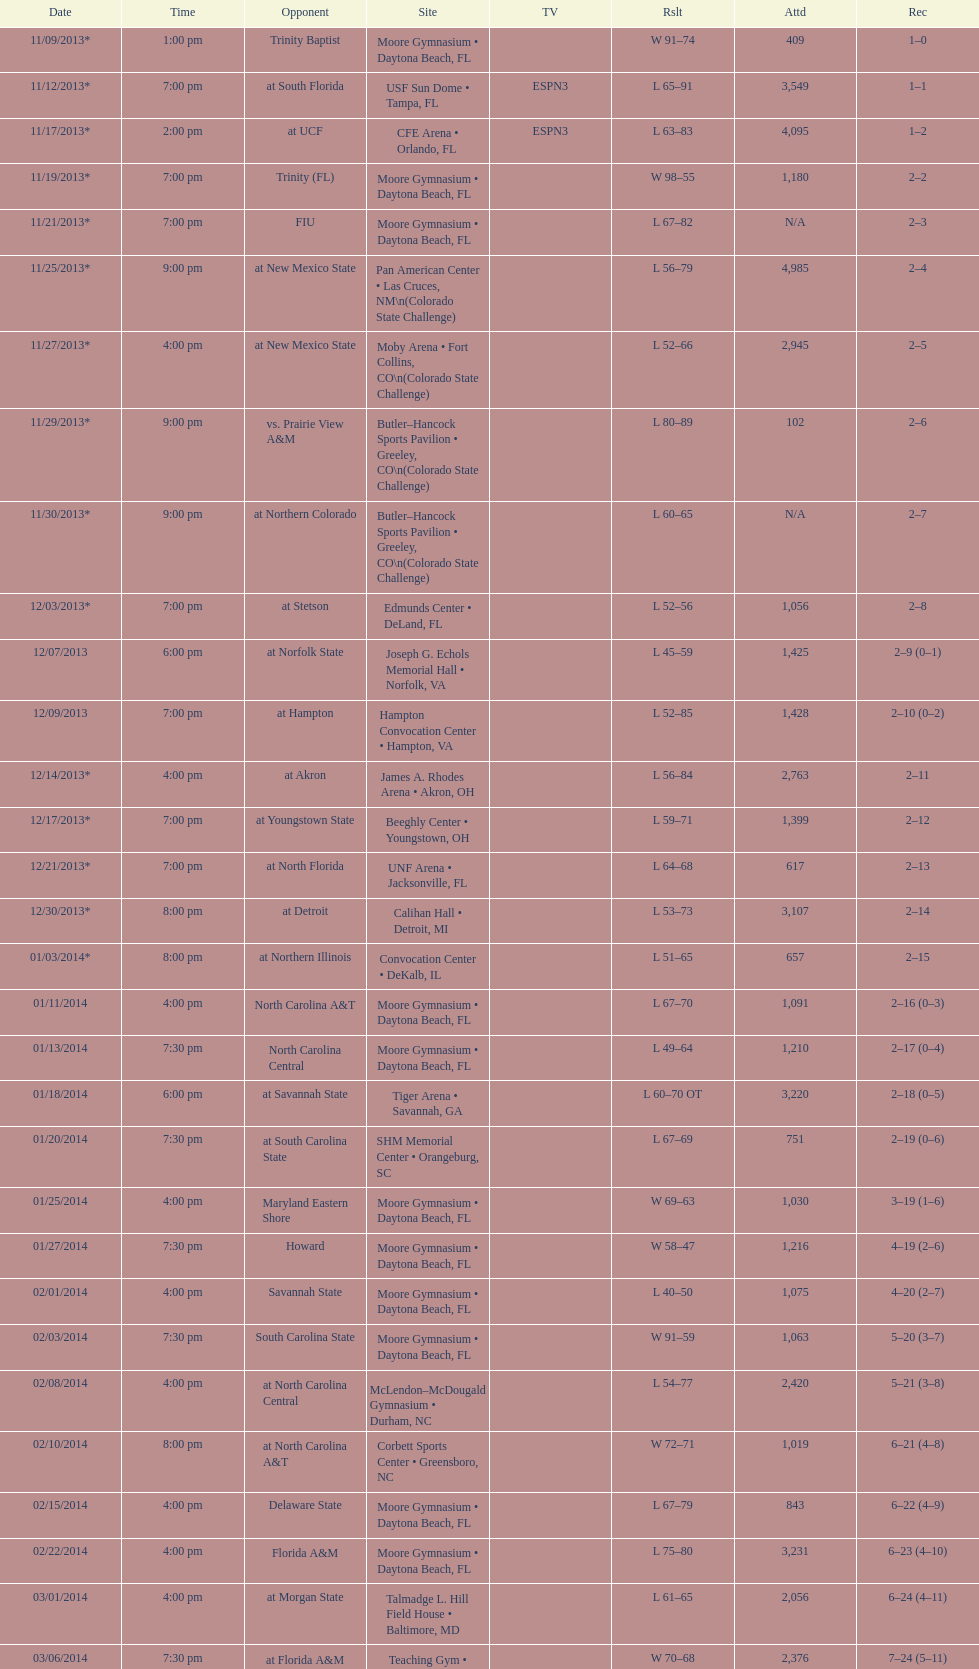How many games had more than 1,500 in attendance? 12. 